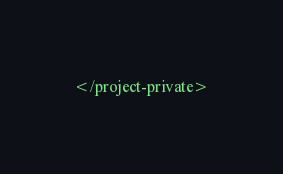Convert code to text. <code><loc_0><loc_0><loc_500><loc_500><_XML_></project-private>
</code> 